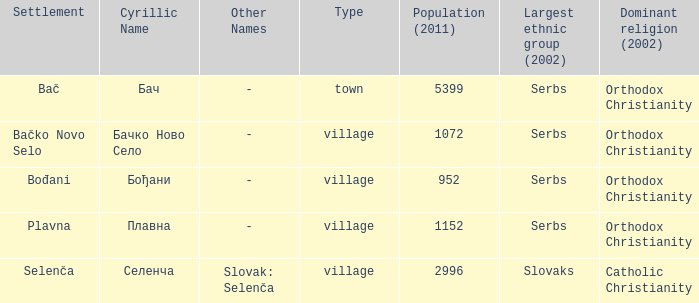What is the smallest population listed? 952.0. 